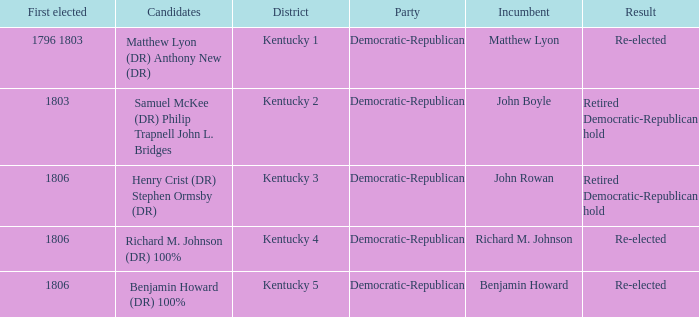Name the candidates for john boyle Samuel McKee (DR) Philip Trapnell John L. Bridges. Write the full table. {'header': ['First elected', 'Candidates', 'District', 'Party', 'Incumbent', 'Result'], 'rows': [['1796 1803', 'Matthew Lyon (DR) Anthony New (DR)', 'Kentucky 1', 'Democratic-Republican', 'Matthew Lyon', 'Re-elected'], ['1803', 'Samuel McKee (DR) Philip Trapnell John L. Bridges', 'Kentucky 2', 'Democratic-Republican', 'John Boyle', 'Retired Democratic-Republican hold'], ['1806', 'Henry Crist (DR) Stephen Ormsby (DR)', 'Kentucky 3', 'Democratic-Republican', 'John Rowan', 'Retired Democratic-Republican hold'], ['1806', 'Richard M. Johnson (DR) 100%', 'Kentucky 4', 'Democratic-Republican', 'Richard M. Johnson', 'Re-elected'], ['1806', 'Benjamin Howard (DR) 100%', 'Kentucky 5', 'Democratic-Republican', 'Benjamin Howard', 'Re-elected']]} 